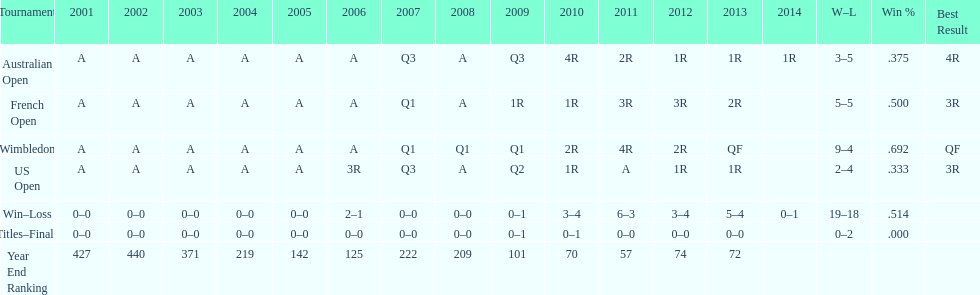What is the difference in wins between wimbledon and the us open for this player? 7. 